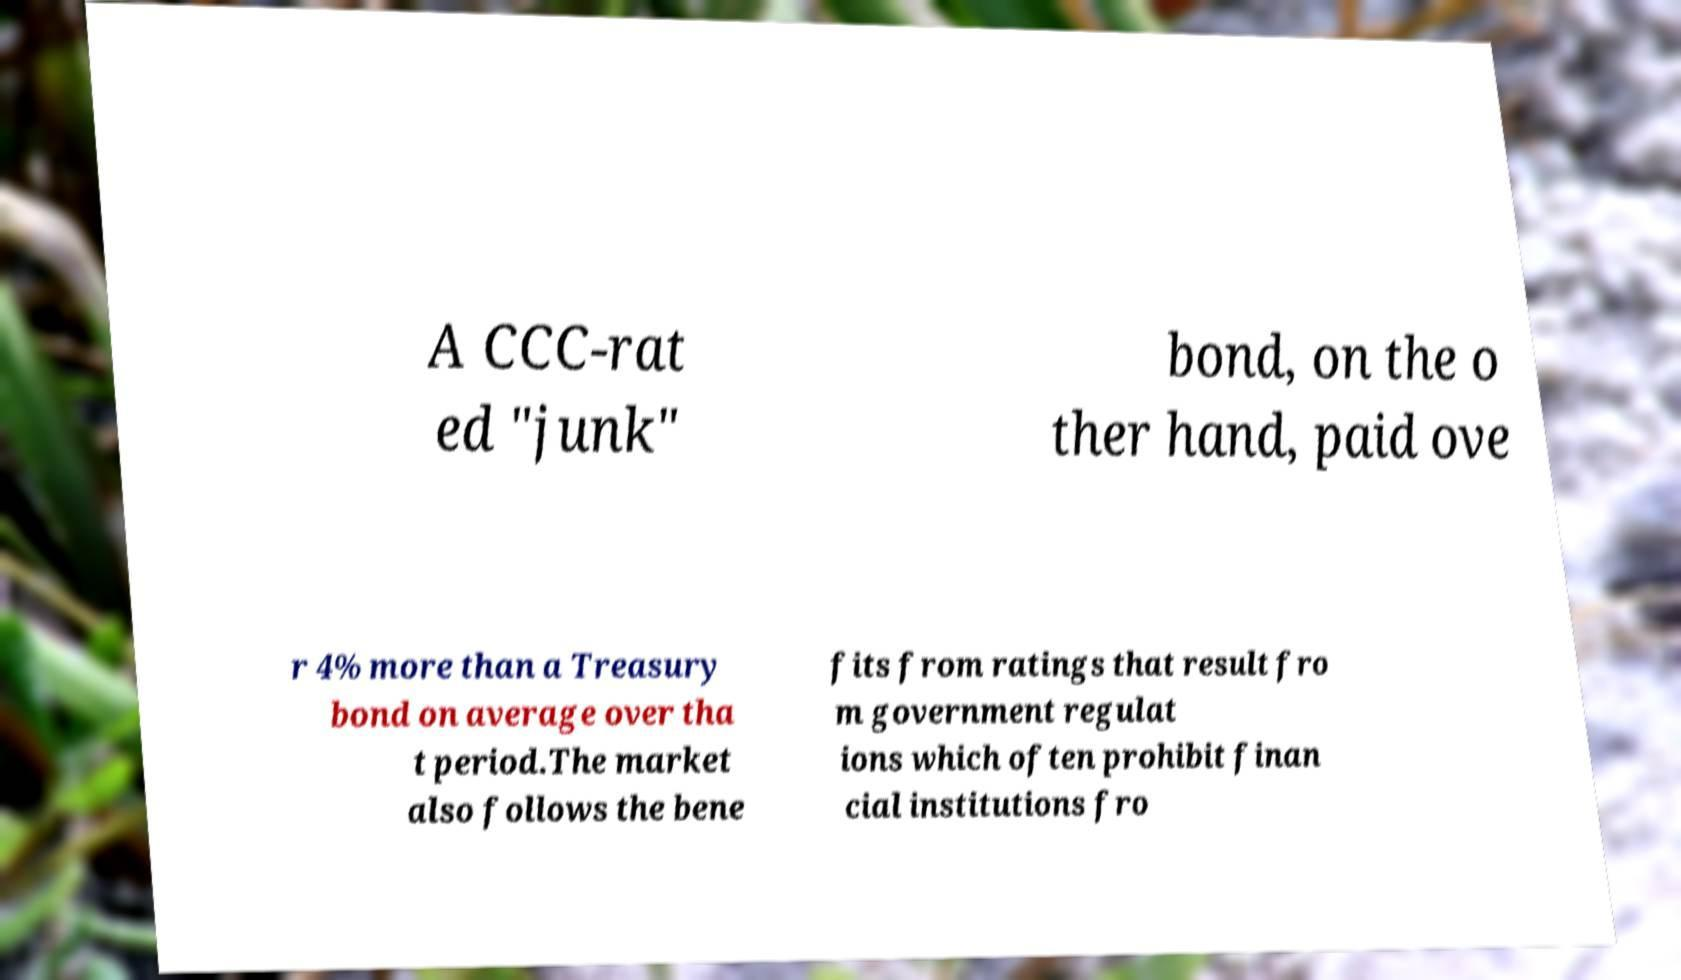I need the written content from this picture converted into text. Can you do that? A CCC-rat ed "junk" bond, on the o ther hand, paid ove r 4% more than a Treasury bond on average over tha t period.The market also follows the bene fits from ratings that result fro m government regulat ions which often prohibit finan cial institutions fro 